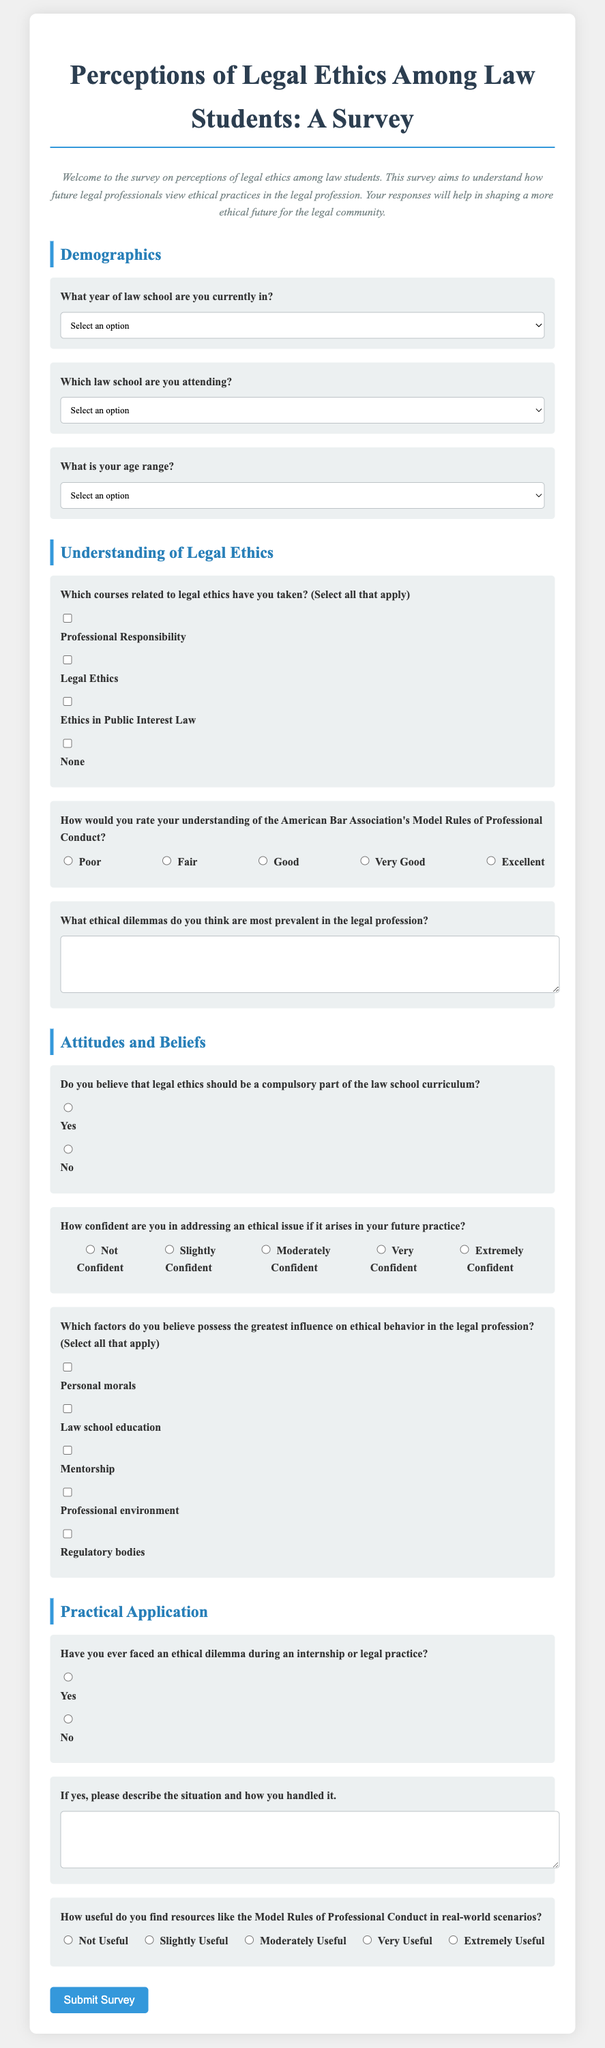What is the title of the survey? The title of the survey is stated at the top of the document, indicating the focus of the research.
Answer: Perceptions of Legal Ethics Among Law Students: A Survey What year of law school is the first selection option for respondents? The first selection option under demographics asks about the year of law school the respondent is currently in.
Answer: 1L Which law school is listed as an option in the survey? One of the options for which law school the respondent is attending is mentioned directly in the document.
Answer: Harvard Law School How would respondents rate their understanding of the ABA Model Rules of Professional Conduct? This question refers to a rating section where respondents gauge their own understanding as part of the survey.
Answer: 1 to 5 Are respondents asked about their confidence in addressing ethical issues? A section on attitudes and beliefs includes a question about respondents' confidence levels in dealing with ethical issues in their future practice.
Answer: Yes Which ethical dilemma-related course is mentioned in the survey? One of the courses related to legal ethics that respondents can choose from is directly mentioned in the survey.
Answer: Professional Responsibility What is the purpose of this survey according to the introduction? The introduction summarizes the overarching goal of the survey in contributing to future ethical practices among legal professionals.
Answer: Understand perceptions of legal ethics How do respondents indicate they have faced an ethical dilemma? The survey contains a specific question regarding respondents' experiences with ethical dilemmas during their internships or legal practice.
Answer: Yes or No What is the last step for participants after completing the survey? The conclusion of the survey includes a clear action for respondents once they have answered all the questions.
Answer: Submit Survey 